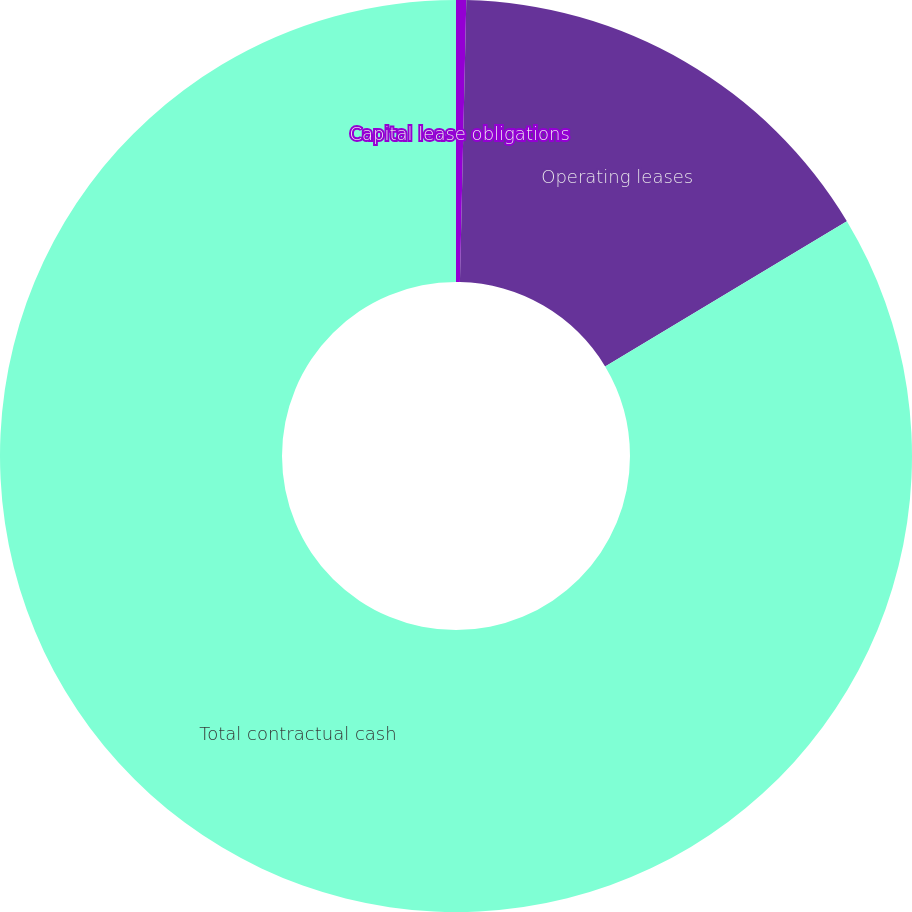<chart> <loc_0><loc_0><loc_500><loc_500><pie_chart><fcel>Capital lease obligations<fcel>Operating leases<fcel>Total contractual cash<nl><fcel>0.36%<fcel>16.03%<fcel>83.61%<nl></chart> 